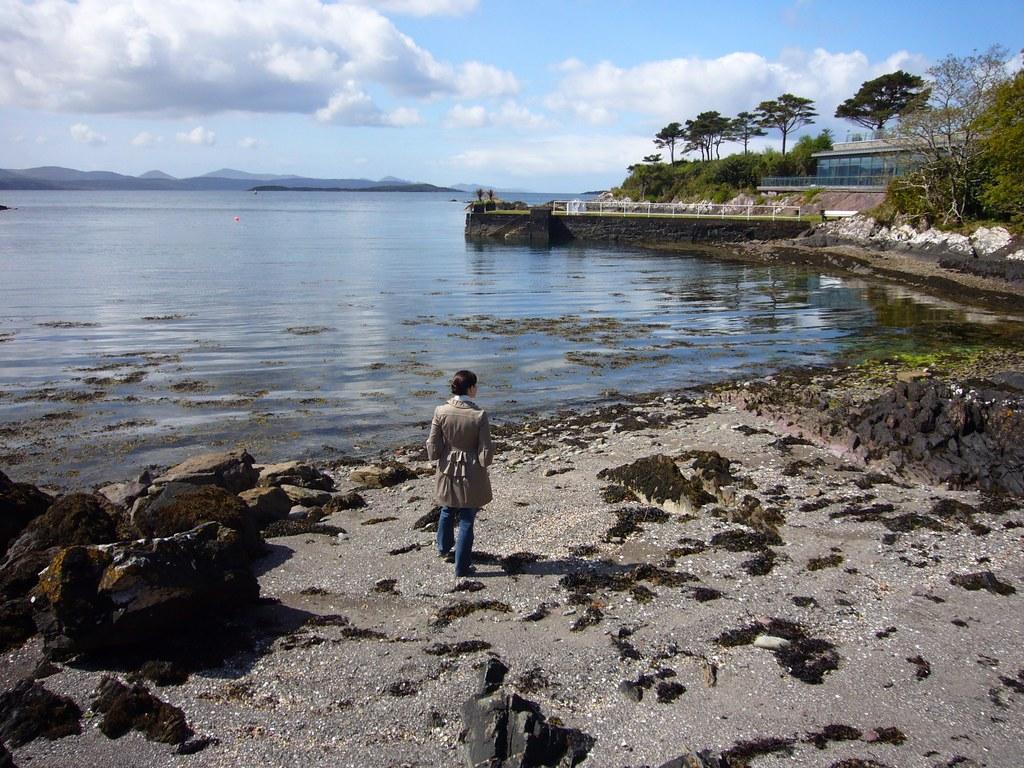Can you describe this image briefly? I the center of the image we can see a woman on the ground. On the right side of the image there is a building, trees, plants, fencing and grass. In the background there is a water, hills, sky and clouds. 